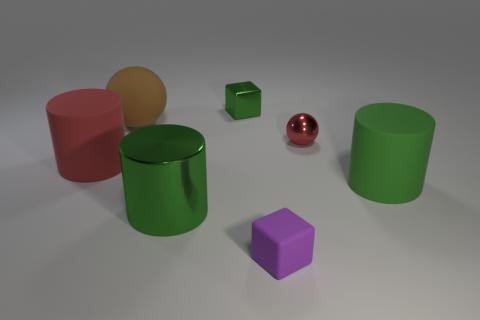Add 3 tiny green shiny cubes. How many objects exist? 10 Subtract all spheres. How many objects are left? 5 Add 4 big rubber objects. How many big rubber objects are left? 7 Add 5 tiny blue matte cubes. How many tiny blue matte cubes exist? 5 Subtract 0 brown cubes. How many objects are left? 7 Subtract all shiny blocks. Subtract all big gray spheres. How many objects are left? 6 